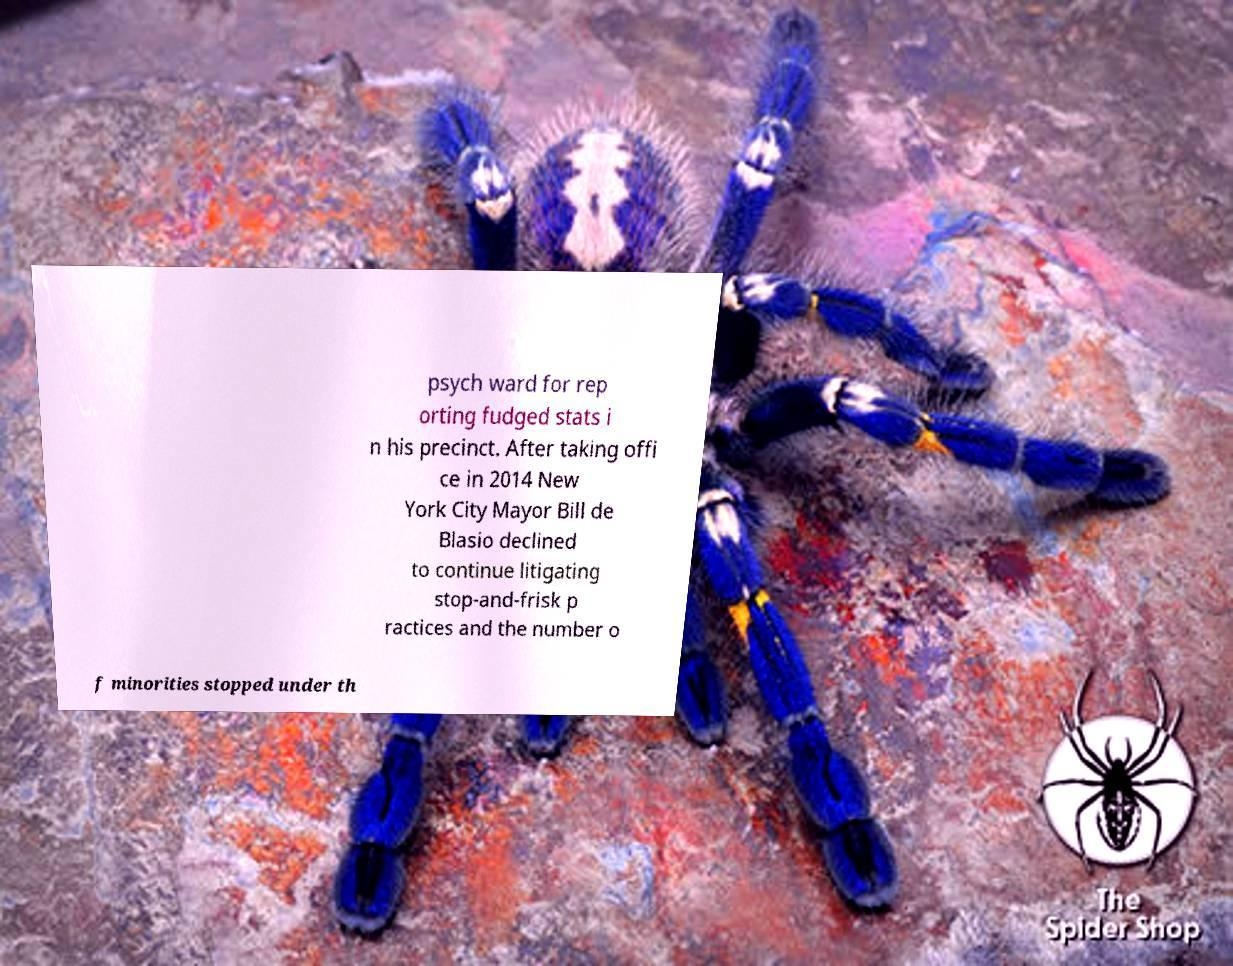There's text embedded in this image that I need extracted. Can you transcribe it verbatim? psych ward for rep orting fudged stats i n his precinct. After taking offi ce in 2014 New York City Mayor Bill de Blasio declined to continue litigating stop-and-frisk p ractices and the number o f minorities stopped under th 